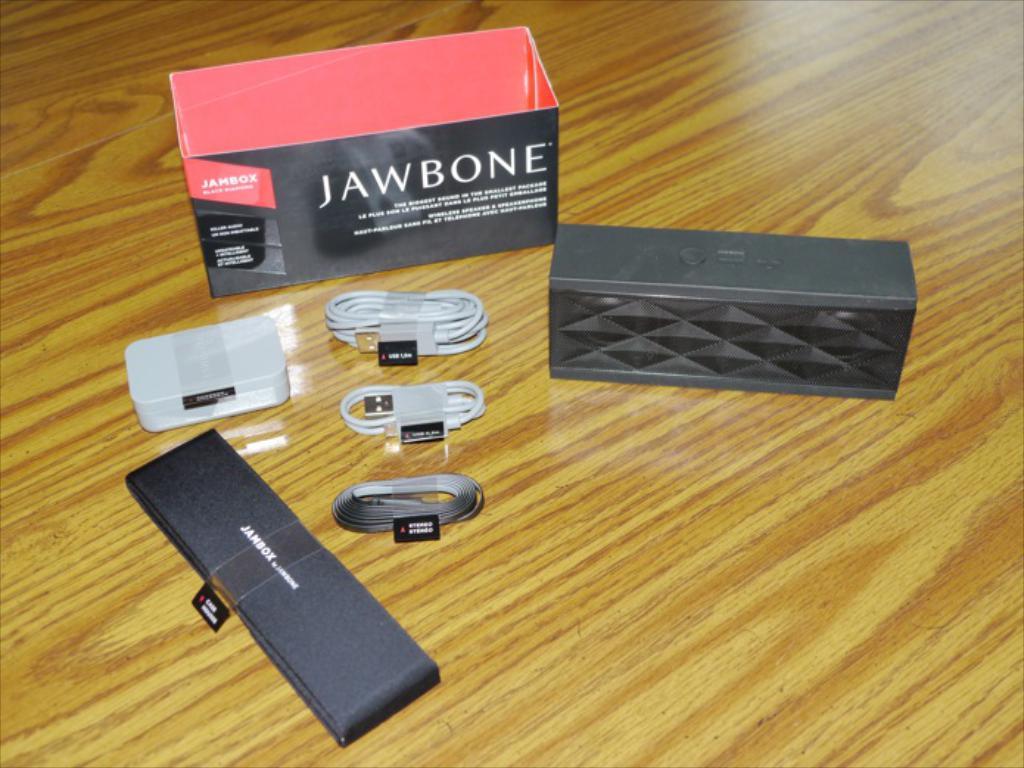Who makes the speaker?
Provide a short and direct response. Jawbone. 